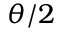Convert formula to latex. <formula><loc_0><loc_0><loc_500><loc_500>\theta / 2</formula> 